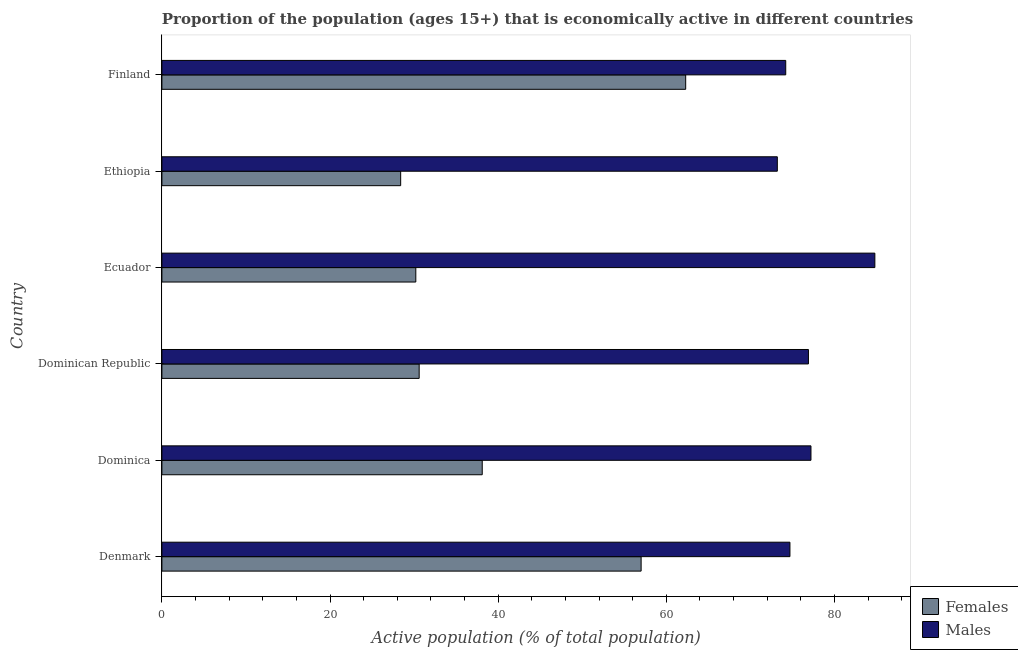How many groups of bars are there?
Your answer should be very brief. 6. Are the number of bars per tick equal to the number of legend labels?
Your answer should be compact. Yes. How many bars are there on the 1st tick from the top?
Offer a terse response. 2. How many bars are there on the 5th tick from the bottom?
Provide a short and direct response. 2. What is the label of the 6th group of bars from the top?
Provide a short and direct response. Denmark. In how many cases, is the number of bars for a given country not equal to the number of legend labels?
Provide a short and direct response. 0. What is the percentage of economically active male population in Dominica?
Keep it short and to the point. 77.2. Across all countries, what is the maximum percentage of economically active male population?
Provide a succinct answer. 84.8. Across all countries, what is the minimum percentage of economically active male population?
Your answer should be very brief. 73.2. In which country was the percentage of economically active male population maximum?
Give a very brief answer. Ecuador. In which country was the percentage of economically active male population minimum?
Your answer should be very brief. Ethiopia. What is the total percentage of economically active female population in the graph?
Keep it short and to the point. 246.6. What is the difference between the percentage of economically active male population in Dominican Republic and the percentage of economically active female population in Dominica?
Offer a terse response. 38.8. What is the average percentage of economically active male population per country?
Provide a succinct answer. 76.83. What is the difference between the percentage of economically active female population and percentage of economically active male population in Denmark?
Your answer should be compact. -17.7. What is the ratio of the percentage of economically active male population in Dominican Republic to that in Ecuador?
Ensure brevity in your answer.  0.91. What is the difference between the highest and the second highest percentage of economically active male population?
Make the answer very short. 7.6. Is the sum of the percentage of economically active female population in Denmark and Ethiopia greater than the maximum percentage of economically active male population across all countries?
Your response must be concise. Yes. What does the 2nd bar from the top in Dominican Republic represents?
Make the answer very short. Females. What does the 2nd bar from the bottom in Denmark represents?
Keep it short and to the point. Males. How many bars are there?
Provide a succinct answer. 12. What is the difference between two consecutive major ticks on the X-axis?
Make the answer very short. 20. Are the values on the major ticks of X-axis written in scientific E-notation?
Your answer should be very brief. No. How are the legend labels stacked?
Your response must be concise. Vertical. What is the title of the graph?
Your response must be concise. Proportion of the population (ages 15+) that is economically active in different countries. Does "Food and tobacco" appear as one of the legend labels in the graph?
Your answer should be very brief. No. What is the label or title of the X-axis?
Ensure brevity in your answer.  Active population (% of total population). What is the Active population (% of total population) in Females in Denmark?
Give a very brief answer. 57. What is the Active population (% of total population) in Males in Denmark?
Your response must be concise. 74.7. What is the Active population (% of total population) in Females in Dominica?
Your answer should be compact. 38.1. What is the Active population (% of total population) in Males in Dominica?
Ensure brevity in your answer.  77.2. What is the Active population (% of total population) of Females in Dominican Republic?
Offer a very short reply. 30.6. What is the Active population (% of total population) of Males in Dominican Republic?
Offer a terse response. 76.9. What is the Active population (% of total population) in Females in Ecuador?
Ensure brevity in your answer.  30.2. What is the Active population (% of total population) in Males in Ecuador?
Offer a terse response. 84.8. What is the Active population (% of total population) of Females in Ethiopia?
Provide a succinct answer. 28.4. What is the Active population (% of total population) of Males in Ethiopia?
Keep it short and to the point. 73.2. What is the Active population (% of total population) in Females in Finland?
Provide a succinct answer. 62.3. What is the Active population (% of total population) of Males in Finland?
Make the answer very short. 74.2. Across all countries, what is the maximum Active population (% of total population) in Females?
Offer a terse response. 62.3. Across all countries, what is the maximum Active population (% of total population) of Males?
Provide a succinct answer. 84.8. Across all countries, what is the minimum Active population (% of total population) of Females?
Provide a short and direct response. 28.4. Across all countries, what is the minimum Active population (% of total population) in Males?
Your answer should be very brief. 73.2. What is the total Active population (% of total population) of Females in the graph?
Offer a very short reply. 246.6. What is the total Active population (% of total population) in Males in the graph?
Offer a very short reply. 461. What is the difference between the Active population (% of total population) of Males in Denmark and that in Dominica?
Give a very brief answer. -2.5. What is the difference between the Active population (% of total population) in Females in Denmark and that in Dominican Republic?
Ensure brevity in your answer.  26.4. What is the difference between the Active population (% of total population) in Males in Denmark and that in Dominican Republic?
Offer a very short reply. -2.2. What is the difference between the Active population (% of total population) in Females in Denmark and that in Ecuador?
Give a very brief answer. 26.8. What is the difference between the Active population (% of total population) in Males in Denmark and that in Ecuador?
Your response must be concise. -10.1. What is the difference between the Active population (% of total population) of Females in Denmark and that in Ethiopia?
Offer a very short reply. 28.6. What is the difference between the Active population (% of total population) of Males in Denmark and that in Finland?
Give a very brief answer. 0.5. What is the difference between the Active population (% of total population) of Males in Dominica and that in Dominican Republic?
Offer a terse response. 0.3. What is the difference between the Active population (% of total population) of Females in Dominica and that in Ethiopia?
Give a very brief answer. 9.7. What is the difference between the Active population (% of total population) of Males in Dominica and that in Ethiopia?
Offer a very short reply. 4. What is the difference between the Active population (% of total population) of Females in Dominica and that in Finland?
Your response must be concise. -24.2. What is the difference between the Active population (% of total population) in Males in Dominica and that in Finland?
Give a very brief answer. 3. What is the difference between the Active population (% of total population) of Males in Dominican Republic and that in Ethiopia?
Offer a very short reply. 3.7. What is the difference between the Active population (% of total population) of Females in Dominican Republic and that in Finland?
Make the answer very short. -31.7. What is the difference between the Active population (% of total population) in Females in Ecuador and that in Ethiopia?
Your answer should be compact. 1.8. What is the difference between the Active population (% of total population) in Females in Ecuador and that in Finland?
Your answer should be very brief. -32.1. What is the difference between the Active population (% of total population) of Males in Ecuador and that in Finland?
Keep it short and to the point. 10.6. What is the difference between the Active population (% of total population) in Females in Ethiopia and that in Finland?
Offer a very short reply. -33.9. What is the difference between the Active population (% of total population) in Males in Ethiopia and that in Finland?
Your answer should be compact. -1. What is the difference between the Active population (% of total population) in Females in Denmark and the Active population (% of total population) in Males in Dominica?
Make the answer very short. -20.2. What is the difference between the Active population (% of total population) in Females in Denmark and the Active population (% of total population) in Males in Dominican Republic?
Your response must be concise. -19.9. What is the difference between the Active population (% of total population) of Females in Denmark and the Active population (% of total population) of Males in Ecuador?
Your response must be concise. -27.8. What is the difference between the Active population (% of total population) of Females in Denmark and the Active population (% of total population) of Males in Ethiopia?
Provide a succinct answer. -16.2. What is the difference between the Active population (% of total population) in Females in Denmark and the Active population (% of total population) in Males in Finland?
Ensure brevity in your answer.  -17.2. What is the difference between the Active population (% of total population) in Females in Dominica and the Active population (% of total population) in Males in Dominican Republic?
Your answer should be compact. -38.8. What is the difference between the Active population (% of total population) in Females in Dominica and the Active population (% of total population) in Males in Ecuador?
Offer a terse response. -46.7. What is the difference between the Active population (% of total population) in Females in Dominica and the Active population (% of total population) in Males in Ethiopia?
Your response must be concise. -35.1. What is the difference between the Active population (% of total population) of Females in Dominica and the Active population (% of total population) of Males in Finland?
Your response must be concise. -36.1. What is the difference between the Active population (% of total population) in Females in Dominican Republic and the Active population (% of total population) in Males in Ecuador?
Provide a short and direct response. -54.2. What is the difference between the Active population (% of total population) of Females in Dominican Republic and the Active population (% of total population) of Males in Ethiopia?
Offer a terse response. -42.6. What is the difference between the Active population (% of total population) in Females in Dominican Republic and the Active population (% of total population) in Males in Finland?
Your response must be concise. -43.6. What is the difference between the Active population (% of total population) in Females in Ecuador and the Active population (% of total population) in Males in Ethiopia?
Your response must be concise. -43. What is the difference between the Active population (% of total population) in Females in Ecuador and the Active population (% of total population) in Males in Finland?
Make the answer very short. -44. What is the difference between the Active population (% of total population) of Females in Ethiopia and the Active population (% of total population) of Males in Finland?
Provide a short and direct response. -45.8. What is the average Active population (% of total population) in Females per country?
Ensure brevity in your answer.  41.1. What is the average Active population (% of total population) in Males per country?
Provide a succinct answer. 76.83. What is the difference between the Active population (% of total population) in Females and Active population (% of total population) in Males in Denmark?
Keep it short and to the point. -17.7. What is the difference between the Active population (% of total population) in Females and Active population (% of total population) in Males in Dominica?
Make the answer very short. -39.1. What is the difference between the Active population (% of total population) in Females and Active population (% of total population) in Males in Dominican Republic?
Your answer should be compact. -46.3. What is the difference between the Active population (% of total population) in Females and Active population (% of total population) in Males in Ecuador?
Offer a terse response. -54.6. What is the difference between the Active population (% of total population) of Females and Active population (% of total population) of Males in Ethiopia?
Ensure brevity in your answer.  -44.8. What is the ratio of the Active population (% of total population) in Females in Denmark to that in Dominica?
Provide a short and direct response. 1.5. What is the ratio of the Active population (% of total population) of Males in Denmark to that in Dominica?
Make the answer very short. 0.97. What is the ratio of the Active population (% of total population) of Females in Denmark to that in Dominican Republic?
Provide a short and direct response. 1.86. What is the ratio of the Active population (% of total population) in Males in Denmark to that in Dominican Republic?
Provide a short and direct response. 0.97. What is the ratio of the Active population (% of total population) in Females in Denmark to that in Ecuador?
Provide a succinct answer. 1.89. What is the ratio of the Active population (% of total population) in Males in Denmark to that in Ecuador?
Offer a very short reply. 0.88. What is the ratio of the Active population (% of total population) in Females in Denmark to that in Ethiopia?
Keep it short and to the point. 2.01. What is the ratio of the Active population (% of total population) in Males in Denmark to that in Ethiopia?
Provide a short and direct response. 1.02. What is the ratio of the Active population (% of total population) of Females in Denmark to that in Finland?
Provide a succinct answer. 0.91. What is the ratio of the Active population (% of total population) in Females in Dominica to that in Dominican Republic?
Ensure brevity in your answer.  1.25. What is the ratio of the Active population (% of total population) in Males in Dominica to that in Dominican Republic?
Give a very brief answer. 1. What is the ratio of the Active population (% of total population) in Females in Dominica to that in Ecuador?
Ensure brevity in your answer.  1.26. What is the ratio of the Active population (% of total population) in Males in Dominica to that in Ecuador?
Keep it short and to the point. 0.91. What is the ratio of the Active population (% of total population) of Females in Dominica to that in Ethiopia?
Your answer should be very brief. 1.34. What is the ratio of the Active population (% of total population) of Males in Dominica to that in Ethiopia?
Make the answer very short. 1.05. What is the ratio of the Active population (% of total population) of Females in Dominica to that in Finland?
Provide a succinct answer. 0.61. What is the ratio of the Active population (% of total population) of Males in Dominica to that in Finland?
Your response must be concise. 1.04. What is the ratio of the Active population (% of total population) in Females in Dominican Republic to that in Ecuador?
Your answer should be compact. 1.01. What is the ratio of the Active population (% of total population) in Males in Dominican Republic to that in Ecuador?
Ensure brevity in your answer.  0.91. What is the ratio of the Active population (% of total population) of Females in Dominican Republic to that in Ethiopia?
Your answer should be compact. 1.08. What is the ratio of the Active population (% of total population) of Males in Dominican Republic to that in Ethiopia?
Your answer should be compact. 1.05. What is the ratio of the Active population (% of total population) of Females in Dominican Republic to that in Finland?
Provide a succinct answer. 0.49. What is the ratio of the Active population (% of total population) in Males in Dominican Republic to that in Finland?
Ensure brevity in your answer.  1.04. What is the ratio of the Active population (% of total population) in Females in Ecuador to that in Ethiopia?
Provide a short and direct response. 1.06. What is the ratio of the Active population (% of total population) of Males in Ecuador to that in Ethiopia?
Keep it short and to the point. 1.16. What is the ratio of the Active population (% of total population) of Females in Ecuador to that in Finland?
Ensure brevity in your answer.  0.48. What is the ratio of the Active population (% of total population) in Females in Ethiopia to that in Finland?
Keep it short and to the point. 0.46. What is the ratio of the Active population (% of total population) in Males in Ethiopia to that in Finland?
Your answer should be compact. 0.99. What is the difference between the highest and the second highest Active population (% of total population) in Females?
Offer a terse response. 5.3. What is the difference between the highest and the lowest Active population (% of total population) of Females?
Offer a terse response. 33.9. What is the difference between the highest and the lowest Active population (% of total population) in Males?
Keep it short and to the point. 11.6. 